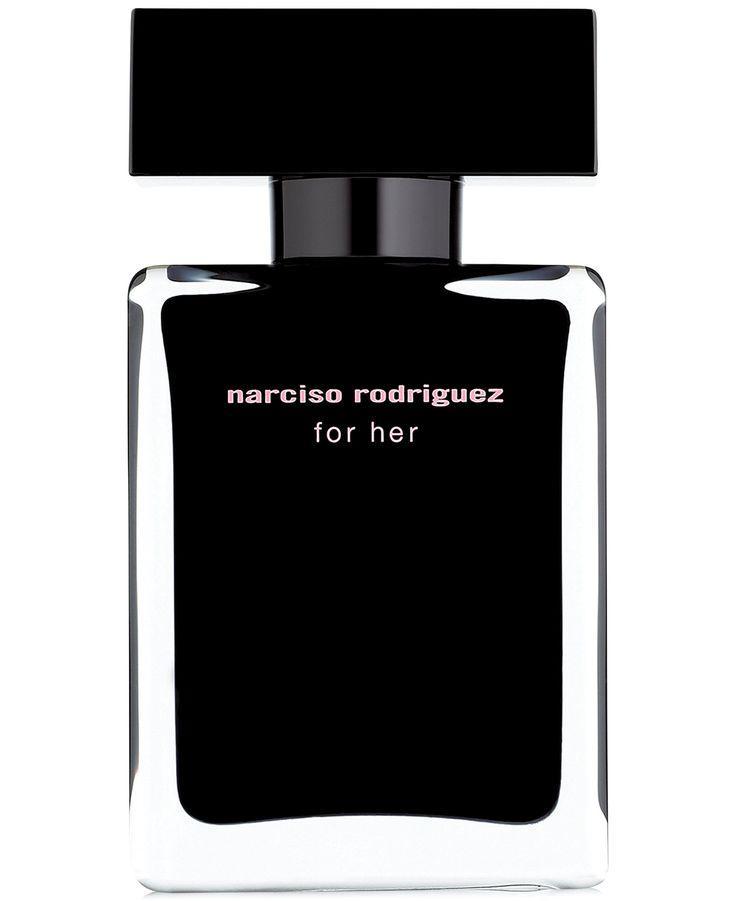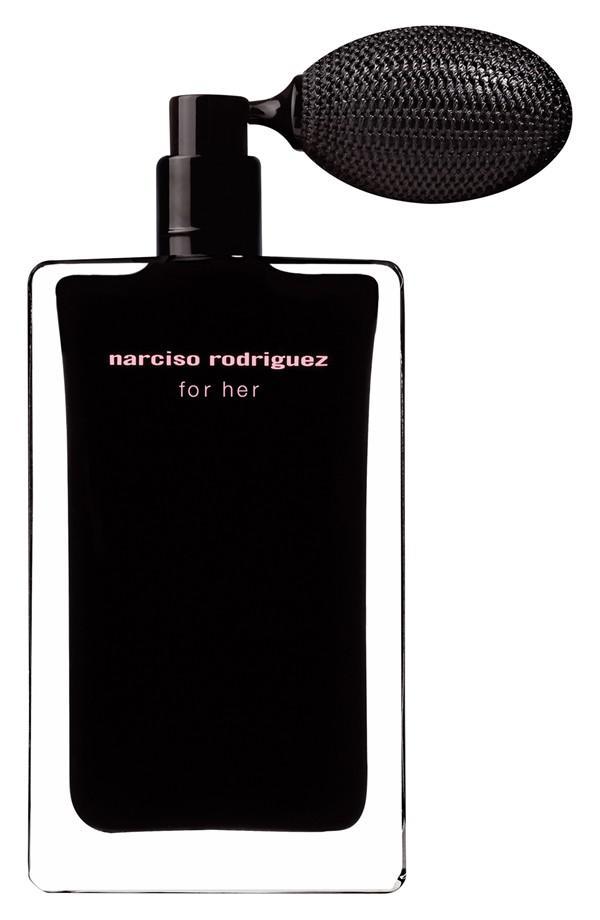The first image is the image on the left, the second image is the image on the right. Examine the images to the left and right. Is the description "One image features a black rectangular container with a flat black lid nearly as wide as the bottle." accurate? Answer yes or no. Yes. 